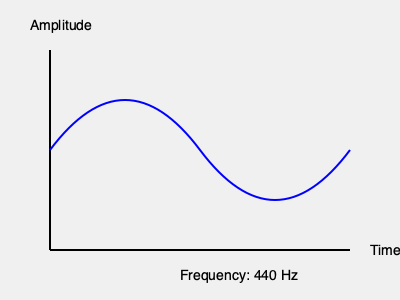As you watch your child's face light up with joy upon hearing their favorite lullaby, you notice the sound wave pattern on their hearing aid display. If the frequency shown is 440 Hz, what musical note is your child likely hearing? To determine the musical note corresponding to a frequency of 440 Hz, we can follow these steps:

1. Recall that 440 Hz is the standard tuning frequency for orchestras and is known as "Concert A."

2. In Western music, the note A above middle C on a piano is tuned to 440 Hz.

3. This frequency is often used as a reference point for tuning instruments and is sometimes called A4 (the fourth A on a standard 88-key piano).

4. The sound wave pattern shown in the graph represents a sine wave, which is a typical representation of a pure tone like the one used for tuning.

5. Given that your child's hearing aid is displaying this frequency, and it corresponds to a common musical note, we can conclude that the child is likely hearing the note A.

6. This A note is often described as being in the middle range of human hearing and is a comfortable listening frequency for most people.

Therefore, based on the frequency of 440 Hz shown on the hearing aid display, your child is most likely hearing the musical note A.
Answer: A 